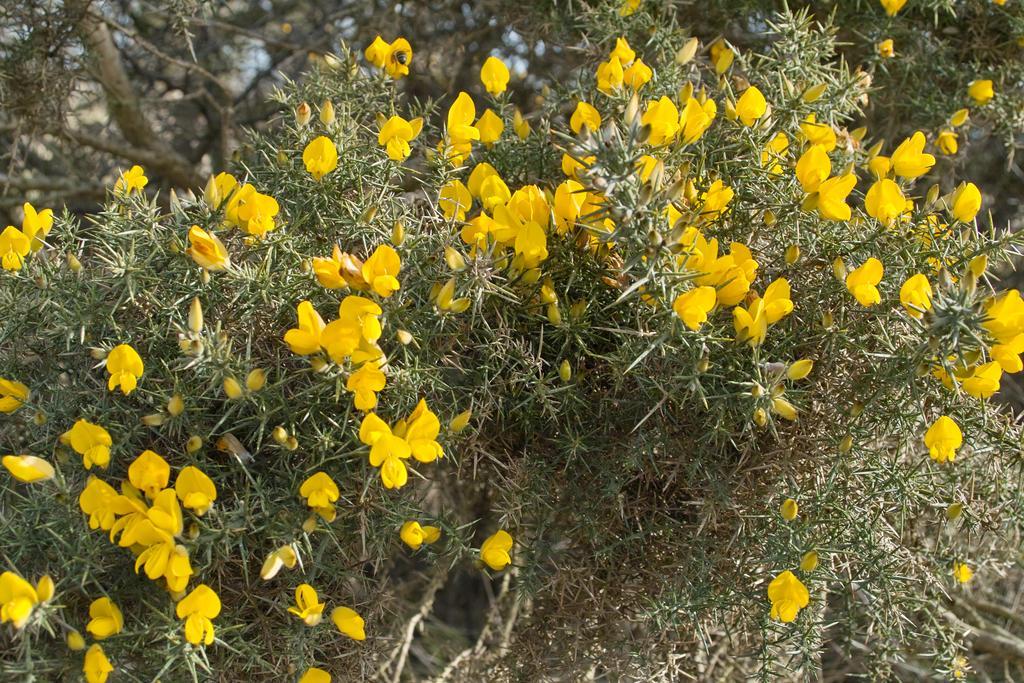Could you give a brief overview of what you see in this image? In this picture I can see some yellow color flowers on plants. In the background I can see trees. 